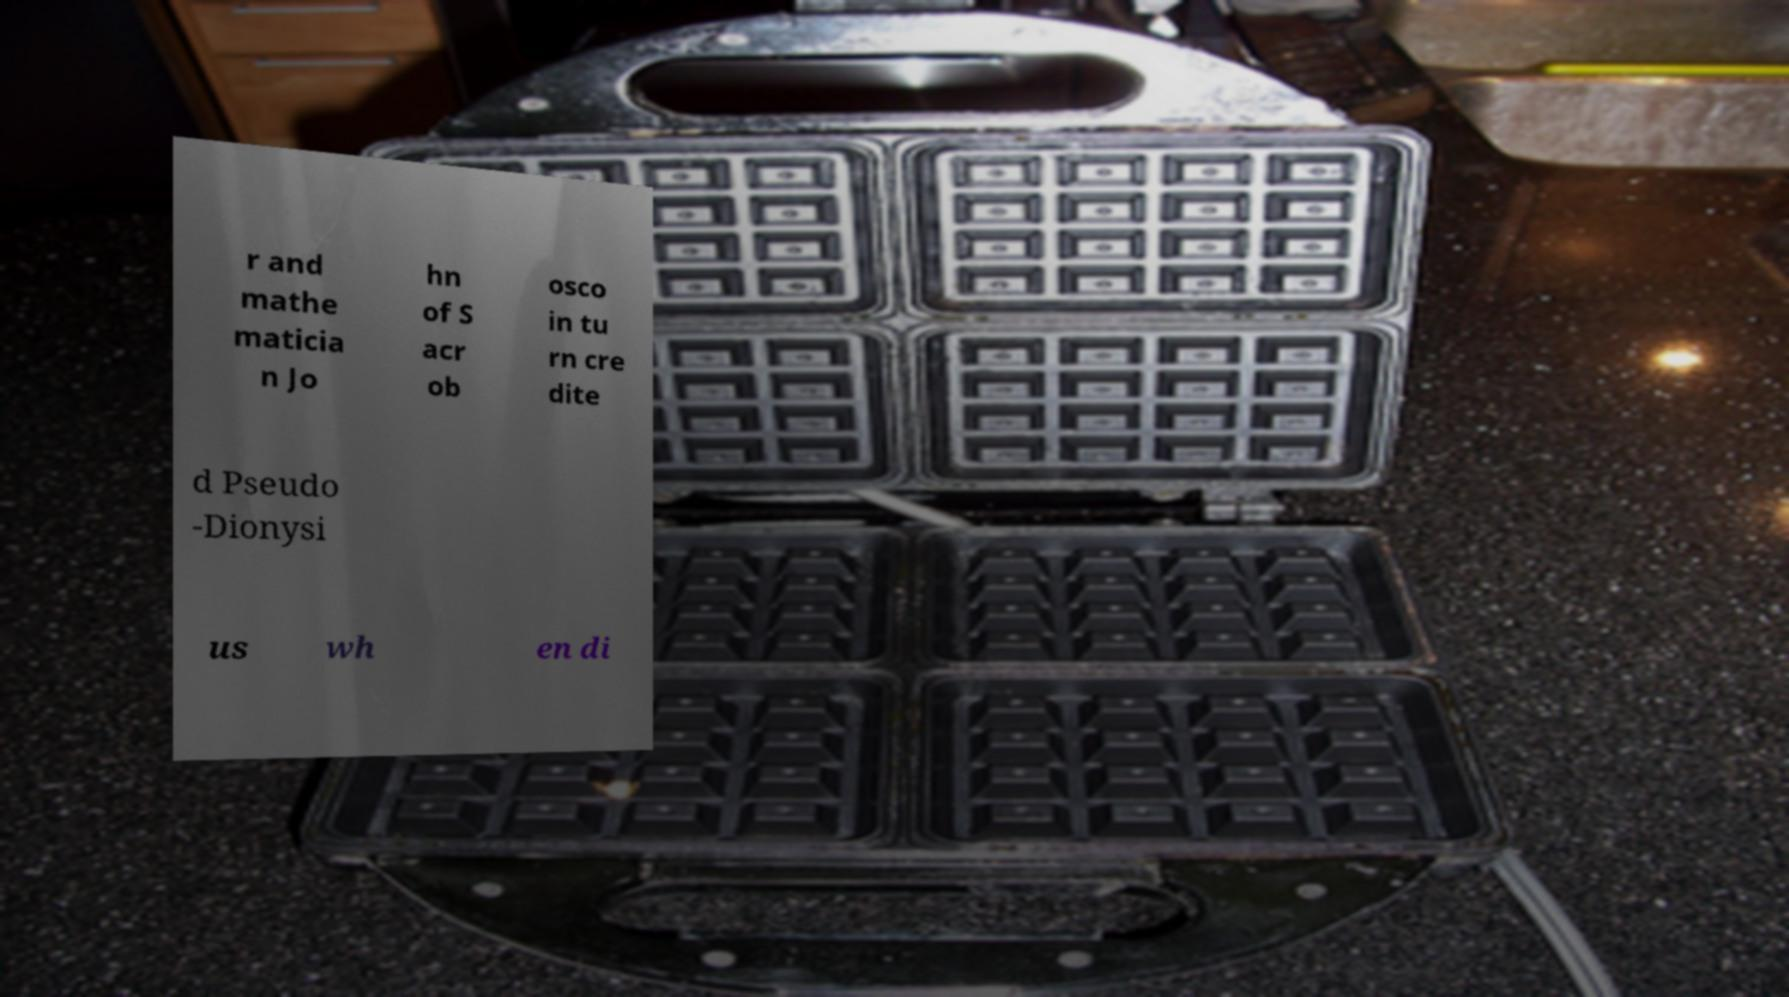There's text embedded in this image that I need extracted. Can you transcribe it verbatim? r and mathe maticia n Jo hn of S acr ob osco in tu rn cre dite d Pseudo -Dionysi us wh en di 